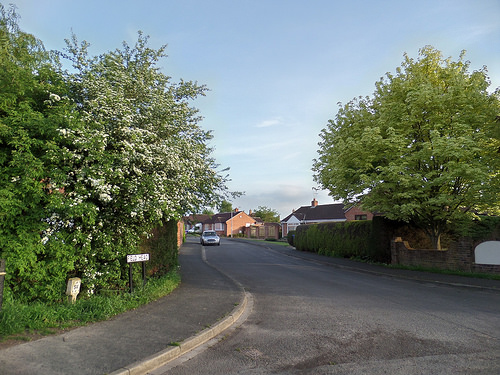<image>
Is the car in front of the building? Yes. The car is positioned in front of the building, appearing closer to the camera viewpoint. 